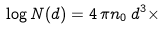Convert formula to latex. <formula><loc_0><loc_0><loc_500><loc_500>\log N ( d ) = 4 \, \pi n _ { 0 } \, d ^ { 3 } \times</formula> 